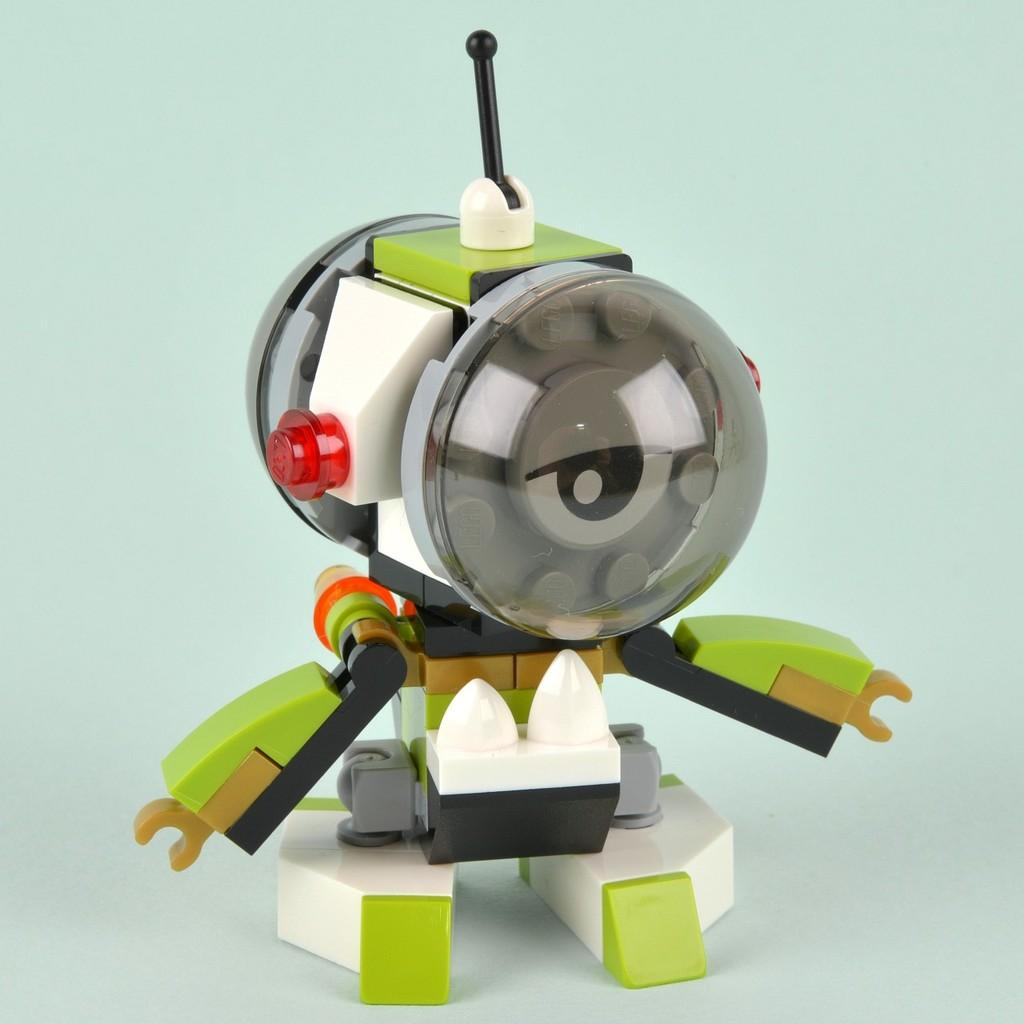What object is present in the image? There is a toy in the image. Where is the toy located? The toy is on a table. What type of wool is being used by the boys in the image? There are no boys or wool present in the image; it only features a toy on a table. 